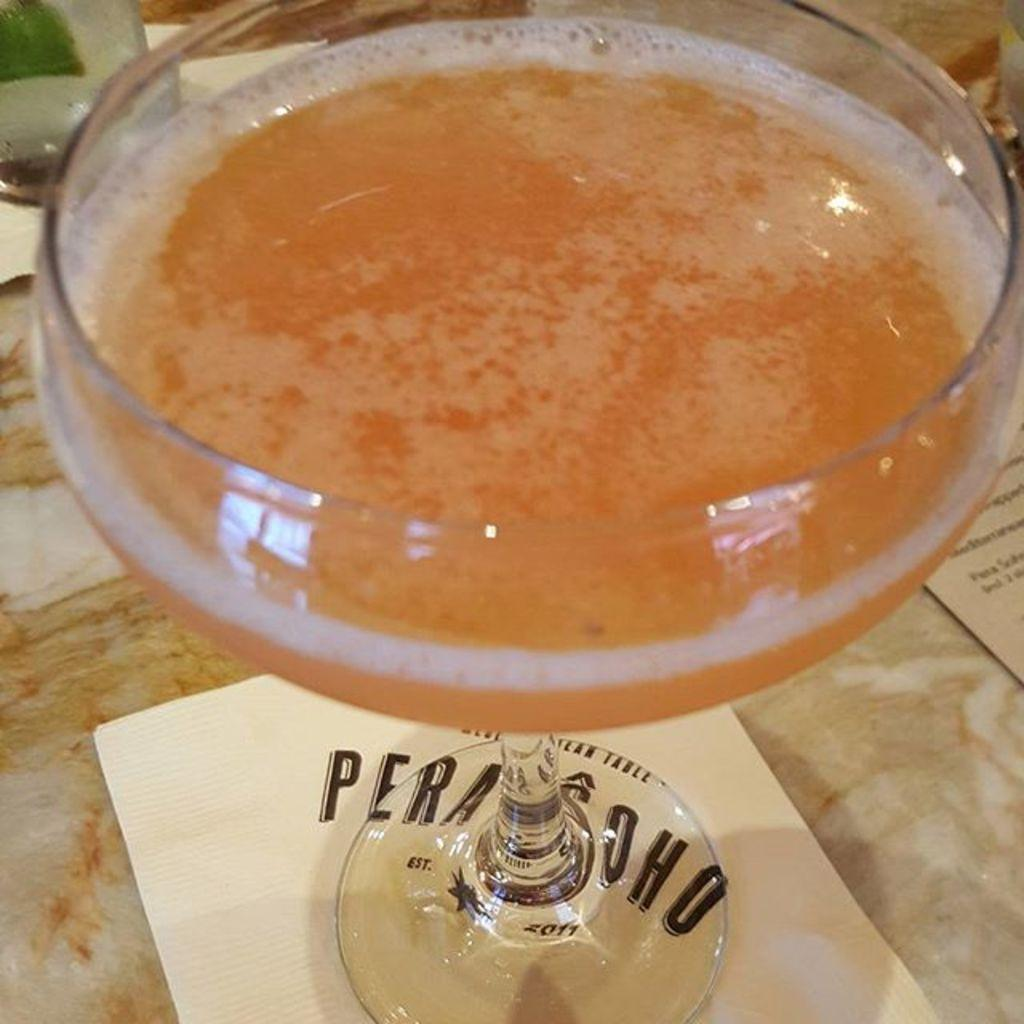What is in the glass that is visible in the image? There is a glass of drink in the image. What is at the bottom of the glass? There is a tissue paper at the bottom of the glass. What is the name of the person who sneezed into the glass? There is no person or sneezing mentioned in the image; it only shows a glass of drink with a tissue paper at the bottom. 